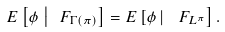Convert formula to latex. <formula><loc_0><loc_0><loc_500><loc_500>E \left [ \phi \, \left | \, \ F _ { \Gamma ( \pi ) } \right ] = E \left [ \phi \, \right | \, \ F _ { L ^ { \pi } } \right ] .</formula> 